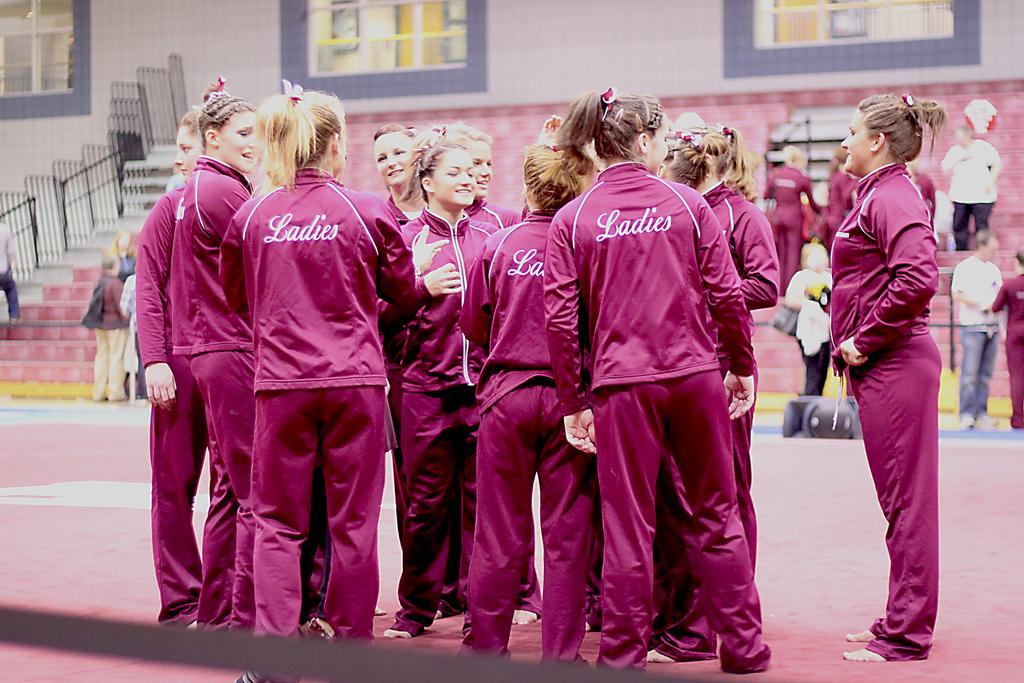<image>
Summarize the visual content of the image. A group of girls are wearing pink sweatsuits with the word Ladies on the back of the tops. 